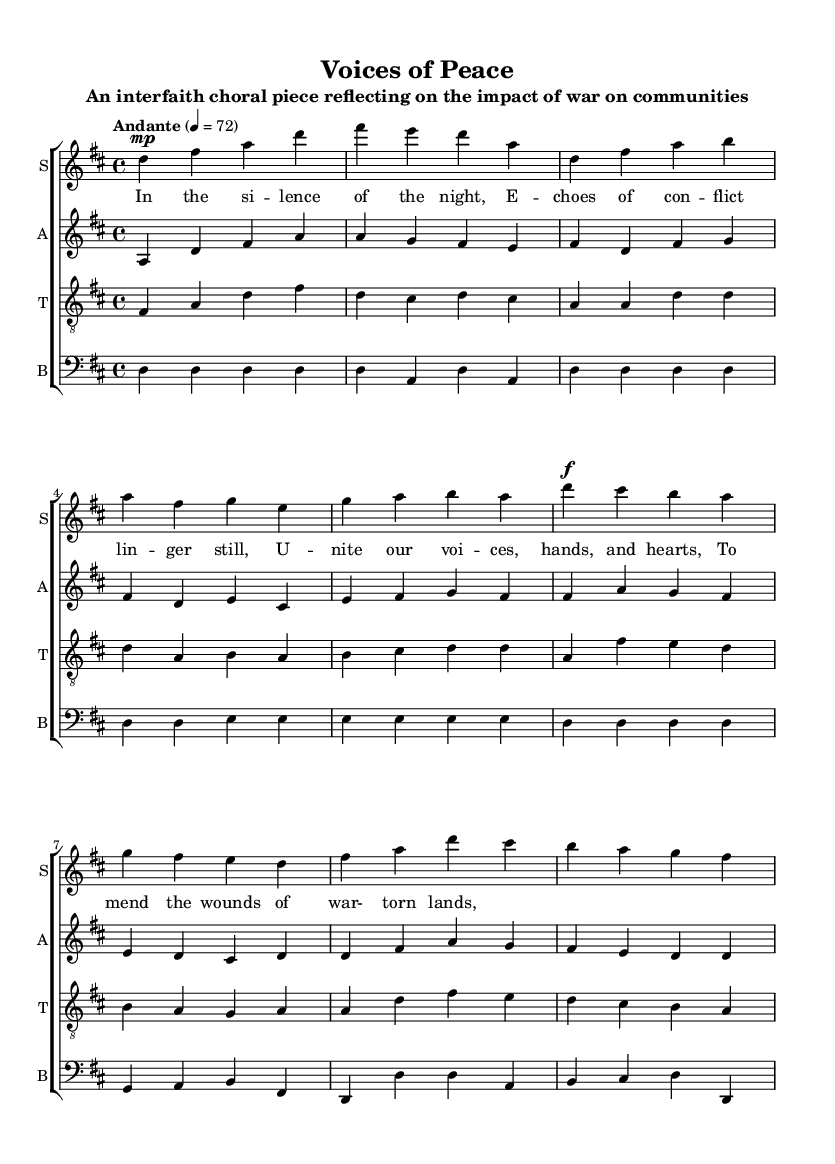What is the key signature of this music? The key signature is indicated at the beginning of the sheet music, and it shows two sharps (F# and C#) which define D major as the key.
Answer: D major What is the time signature of this music? The time signature is found at the beginning, shown as a fraction. It states "4/4", meaning there are four beats in each measure and the quarter note gets one beat.
Answer: 4/4 What is the tempo marking for this piece? The tempo is specified in words above the staff, showing that it should be played at a pace of "Andante" with a speed marking of "4 = 72", indicating the quarter note should be played at 72 beats per minute.
Answer: Andante, 72 How many voices are present in this choral arrangement? By looking at the staves labeled "S," "A," "T," and "B," we can count four separate vocal parts: Soprano, Alto, Tenor, and Bass.
Answer: Four What is the primary theme expressed in the lyrics of the verse? The lyrics reflect sentiments about healing from conflict and coming together to mend the wounds of war-torn communities, which is derived from the thematic words like "silence," "unite," and "wounds."
Answer: Healing from war Which part has the highest vocal range? The Soprano part is written at the highest pitch, as indicated by the placement of the notes relative to the staff, and is conventionally the highest voice in choral music.
Answer: Soprano What musical notation indicates the dynamic level for the first chorus? The dynamic level is noted with the symbol "f" for forte at the beginning of the chorus section, indicating that the music should be played loudly.
Answer: Forte 